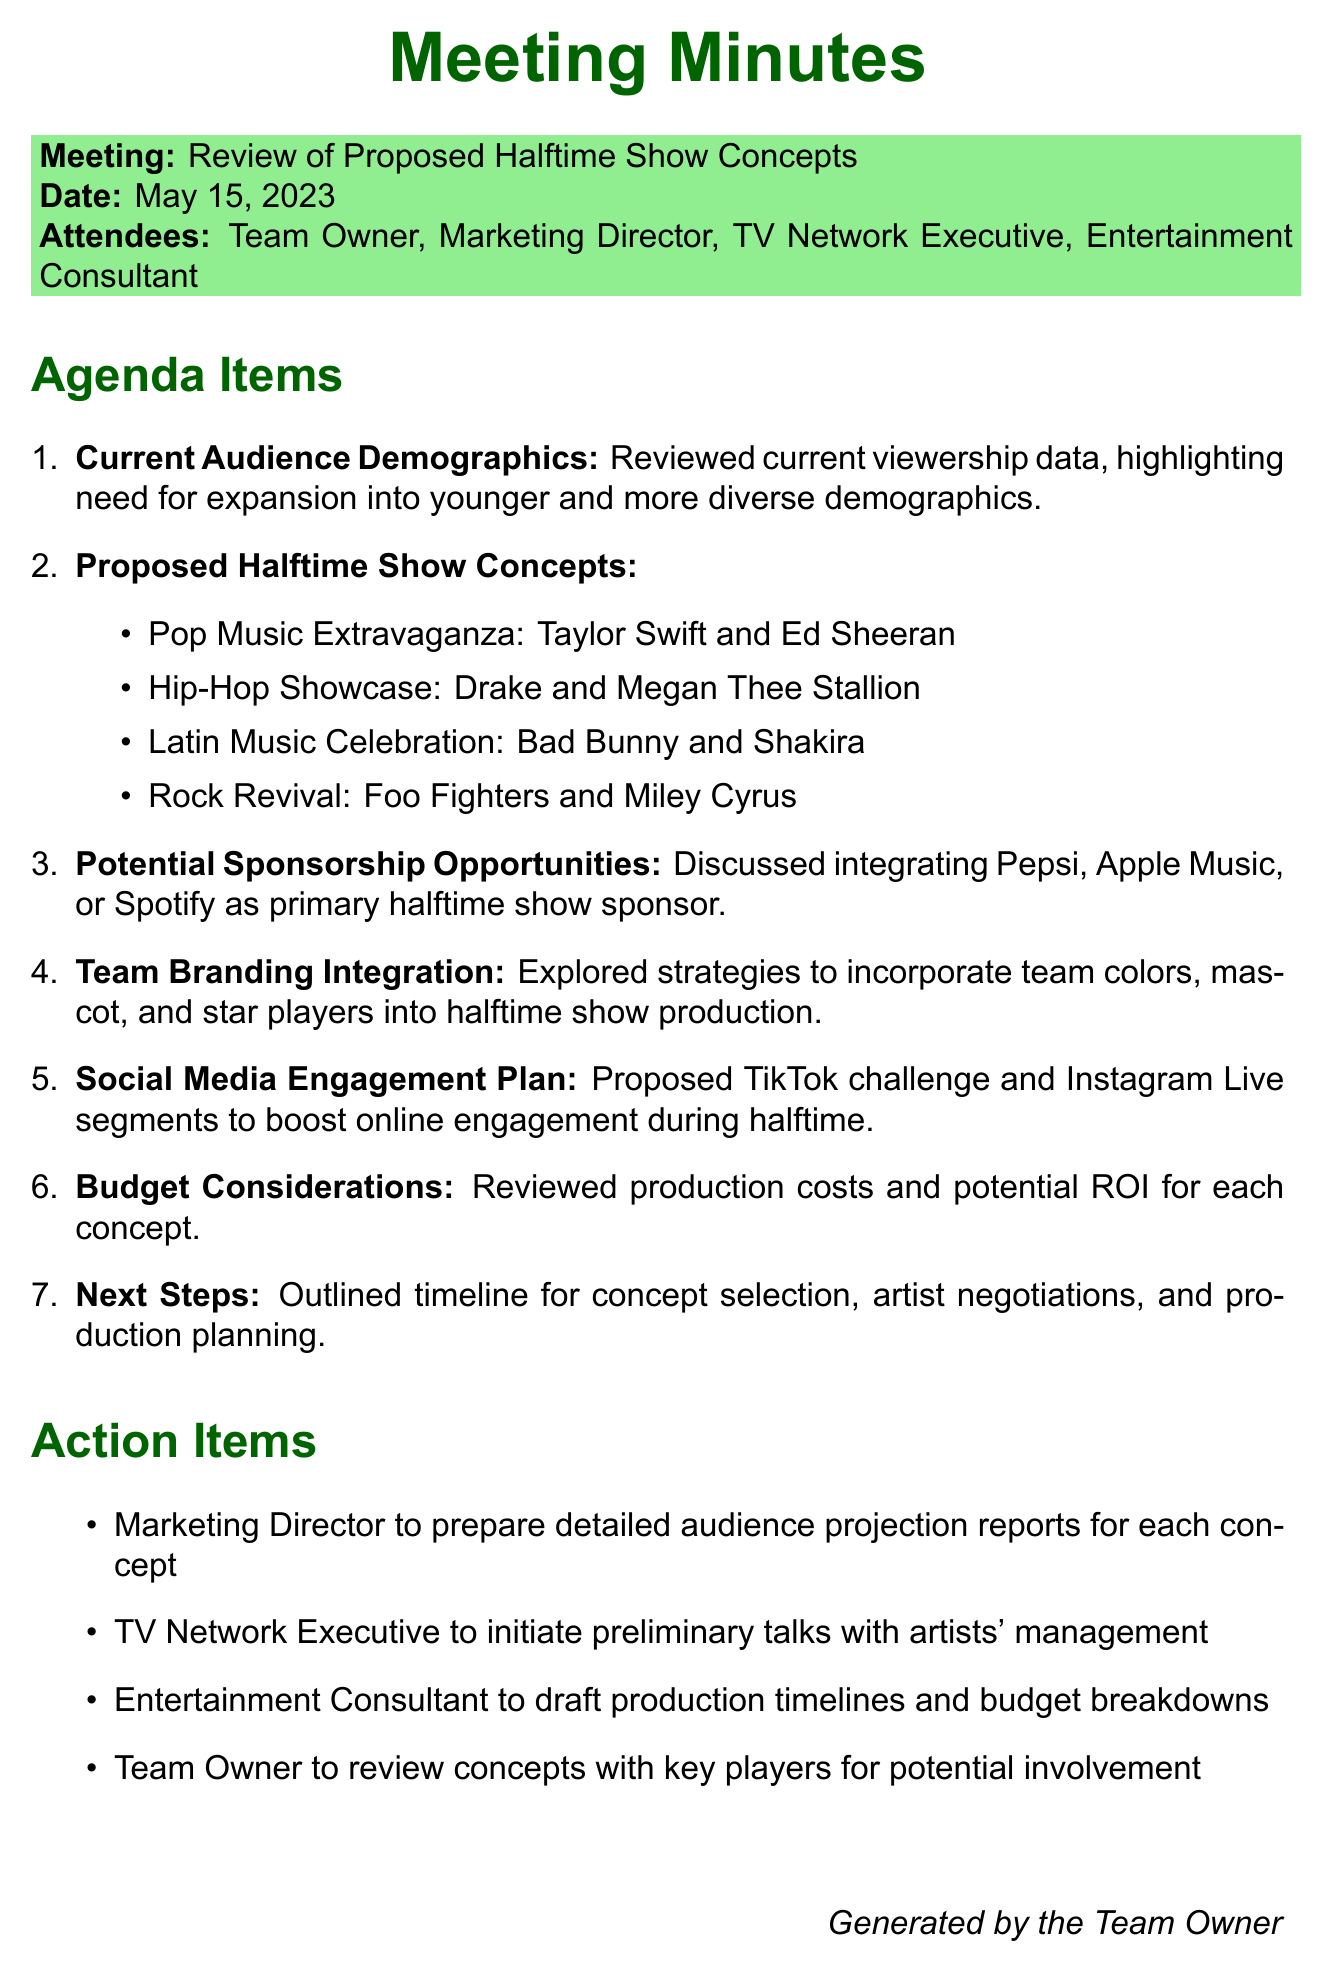what is the date of the meeting? The date of the meeting is explicitly stated in the document.
Answer: May 15, 2023 who proposed the Pop Music Extravaganza? The proposed halftime show concept includes specific artists, indicating they are the key figures associated with it.
Answer: Taylor Swift and Ed Sheeran what is one proposed sponsorship opportunity discussed? The document highlights major brands that could be involved as sponsors during the halftime show.
Answer: Pepsi what demographic is targeted for audience expansion? The meeting focuses on improving viewership by appealing to specific groups, an important consideration for enhancing team visibility.
Answer: younger and more diverse demographics who is responsible for preparing audience projection reports? The document lists action items detailing who will take specific responsibilities after the meeting.
Answer: Marketing Director how many halftime show concepts were proposed? The document enumerates the proposed concepts listed during the meeting.
Answer: four what type of social media engagement was proposed? The document outlines plans for engaging the audience online during the halftime shows.
Answer: TikTok challenge what is the purpose of the meeting? The purpose centers around reviewing concepts that can draw a wider audience, informing the decisions made during the discussions.
Answer: Review of Proposed Halftime Show Concepts what will the TV Network Executive initiate? The action items specify tasks allocated to different attendees post-meeting, revealing their specific next steps.
Answer: preliminary talks with artists' management 